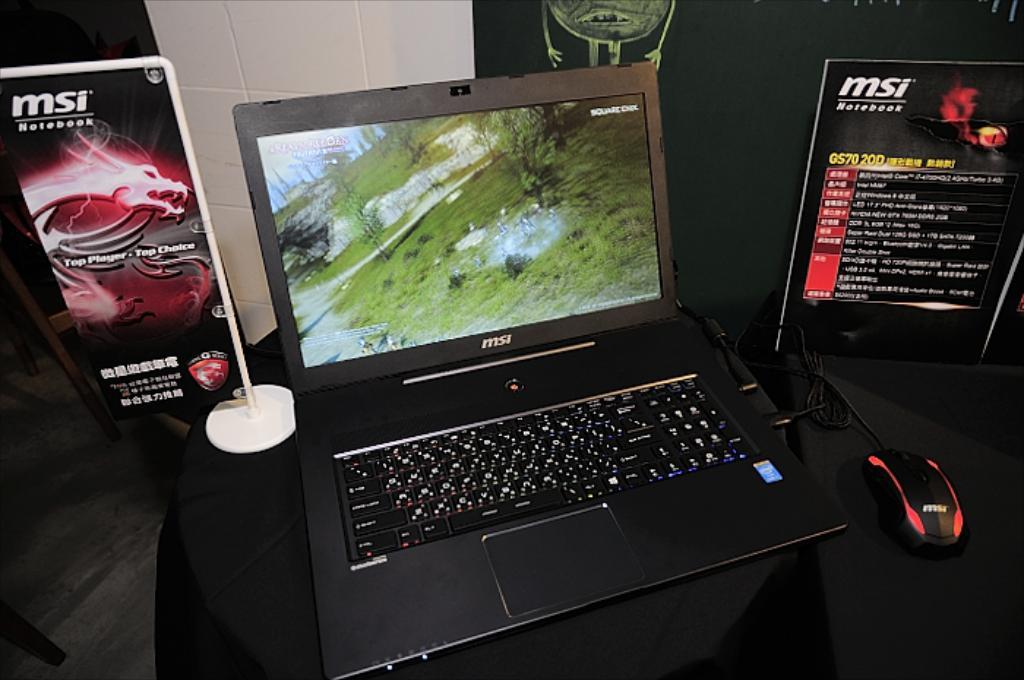<image>
Create a compact narrative representing the image presented. A computer is on display, the MSI notebook 